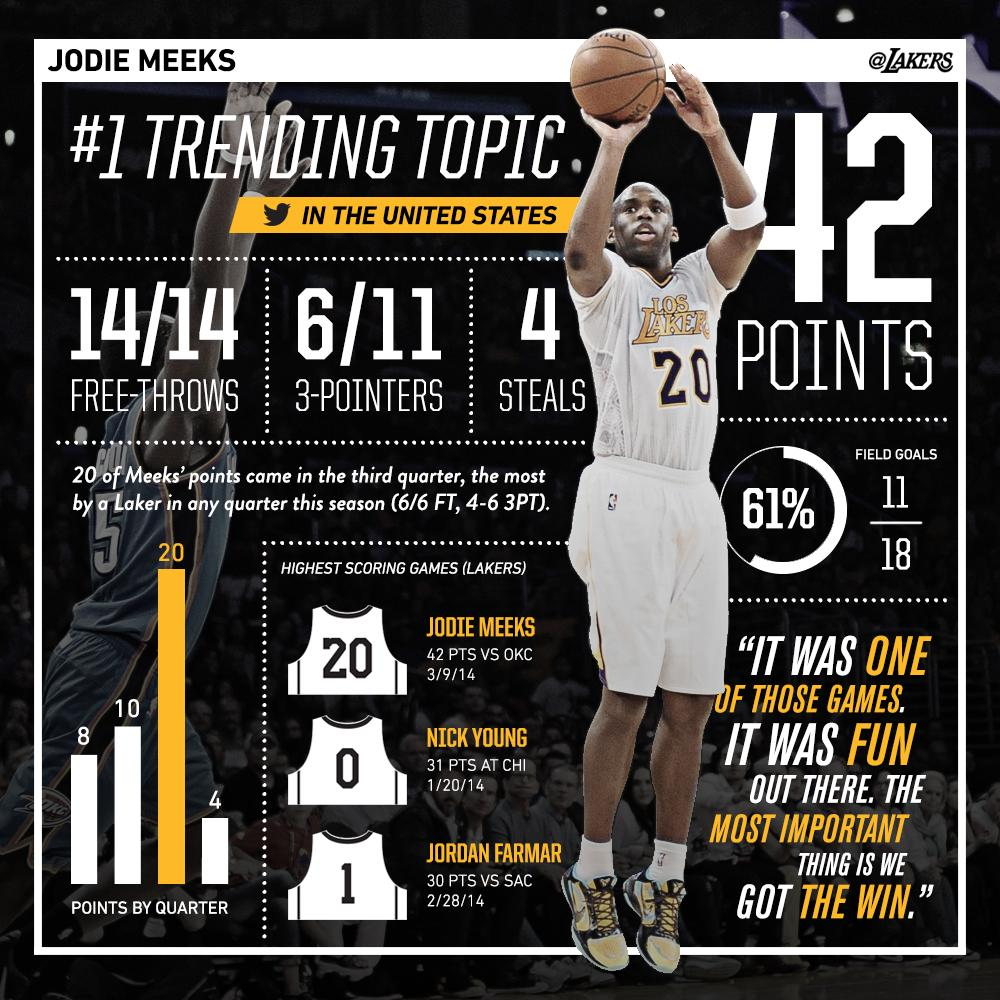Draw attention to some important aspects in this diagram. Jordan Farmar, who wore jersey number one for the Los Angeles Lakers, sported the number during his time with the team. The points scored in the second quarter were 10. I declare that the jersey number of Nick Young is 0. The player in the image is Jodie Meeks, as declared in the sentence "Jodie Meeks... 